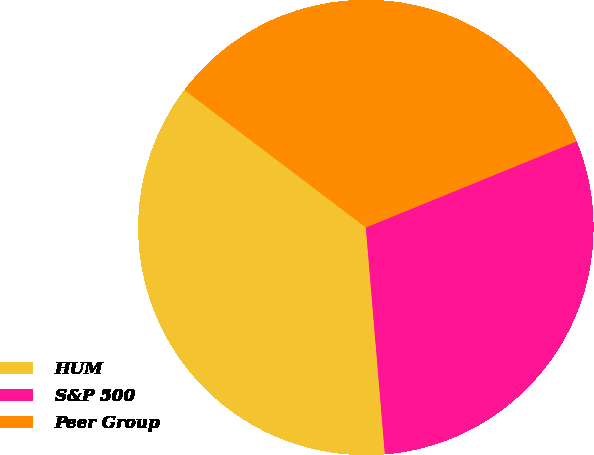Convert chart to OTSL. <chart><loc_0><loc_0><loc_500><loc_500><pie_chart><fcel>HUM<fcel>S&P 500<fcel>Peer Group<nl><fcel>36.65%<fcel>29.84%<fcel>33.51%<nl></chart> 